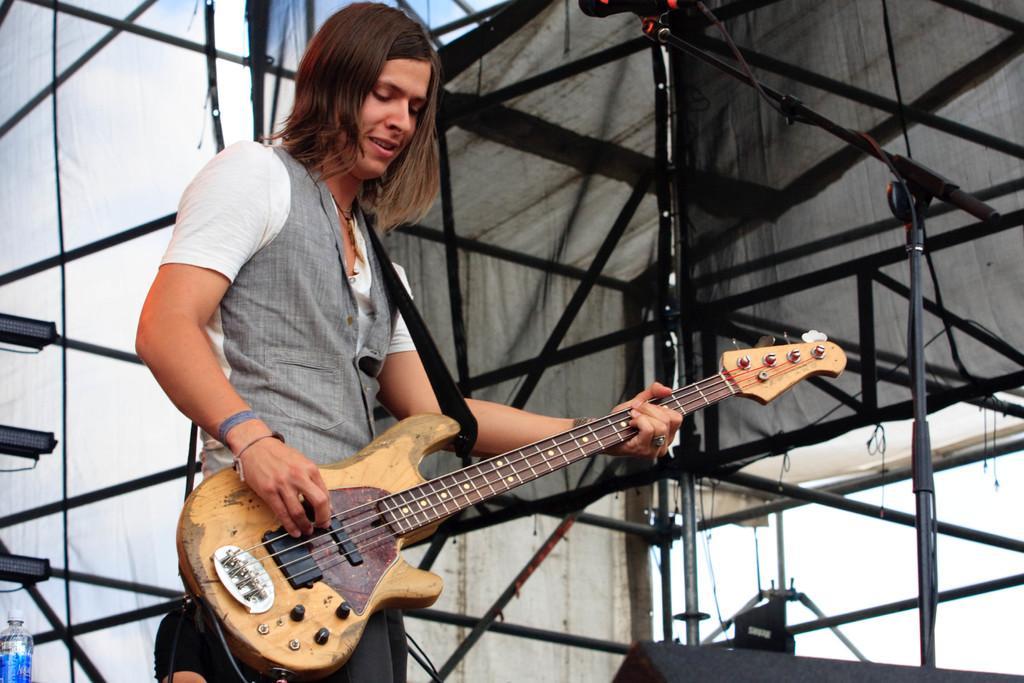How would you summarize this image in a sentence or two? In the picture there is a person standing and holding a guitar. In the background we can find a stand of iron rods. 